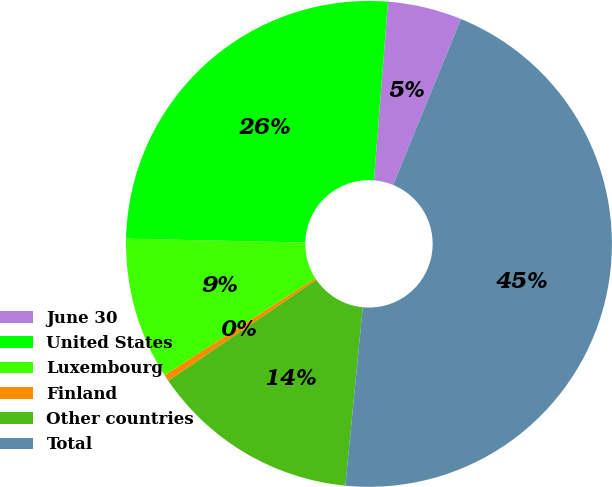Convert chart. <chart><loc_0><loc_0><loc_500><loc_500><pie_chart><fcel>June 30<fcel>United States<fcel>Luxembourg<fcel>Finland<fcel>Other countries<fcel>Total<nl><fcel>4.93%<fcel>25.91%<fcel>9.43%<fcel>0.44%<fcel>13.92%<fcel>45.37%<nl></chart> 